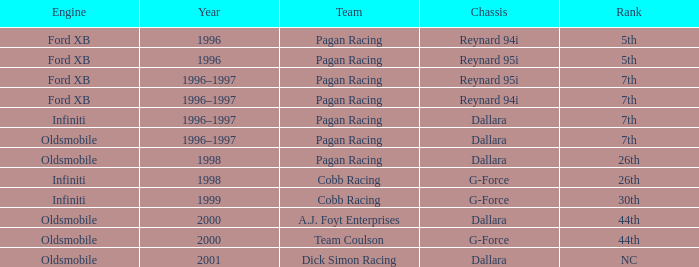With the reynard 95i chassis, which engine managed to secure the 7th position? Ford XB. 